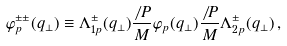<formula> <loc_0><loc_0><loc_500><loc_500>\varphi ^ { \pm \pm } _ { p } ( q _ { \perp } ) \equiv \Lambda ^ { \pm } _ { 1 p } ( q _ { \perp } ) \frac { \not \, { P } } { M } \varphi _ { p } ( q _ { \perp } ) \frac { \not \, { P } } { M } \Lambda ^ { \pm } _ { 2 p } ( q _ { \perp } ) \, ,</formula> 